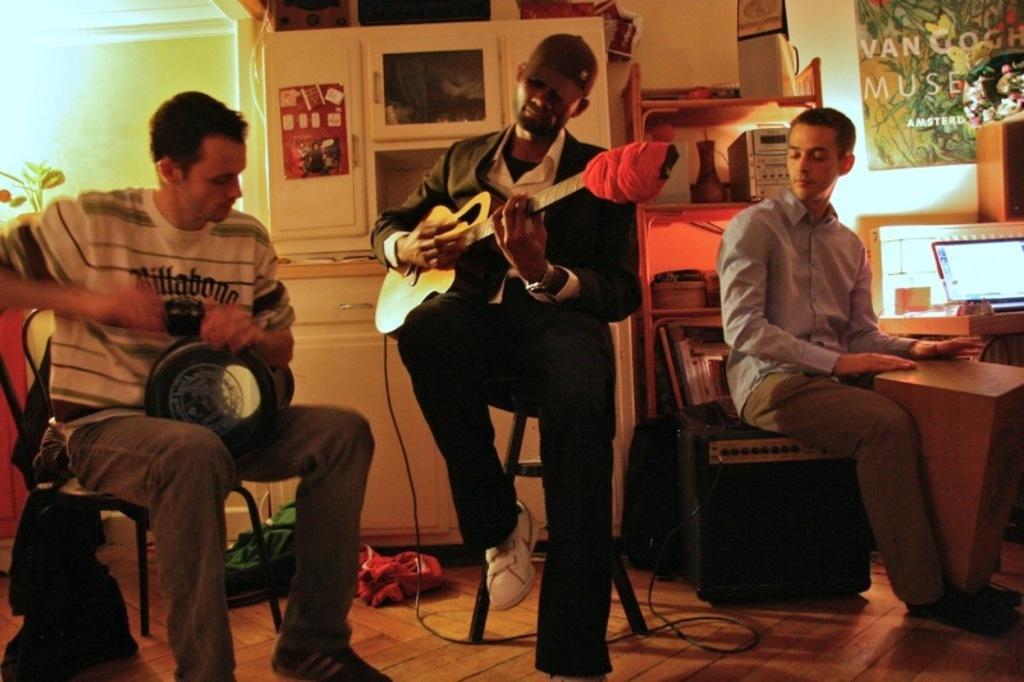Describe this image in one or two sentences. There are three people in a room. They are playing musical instruments. 